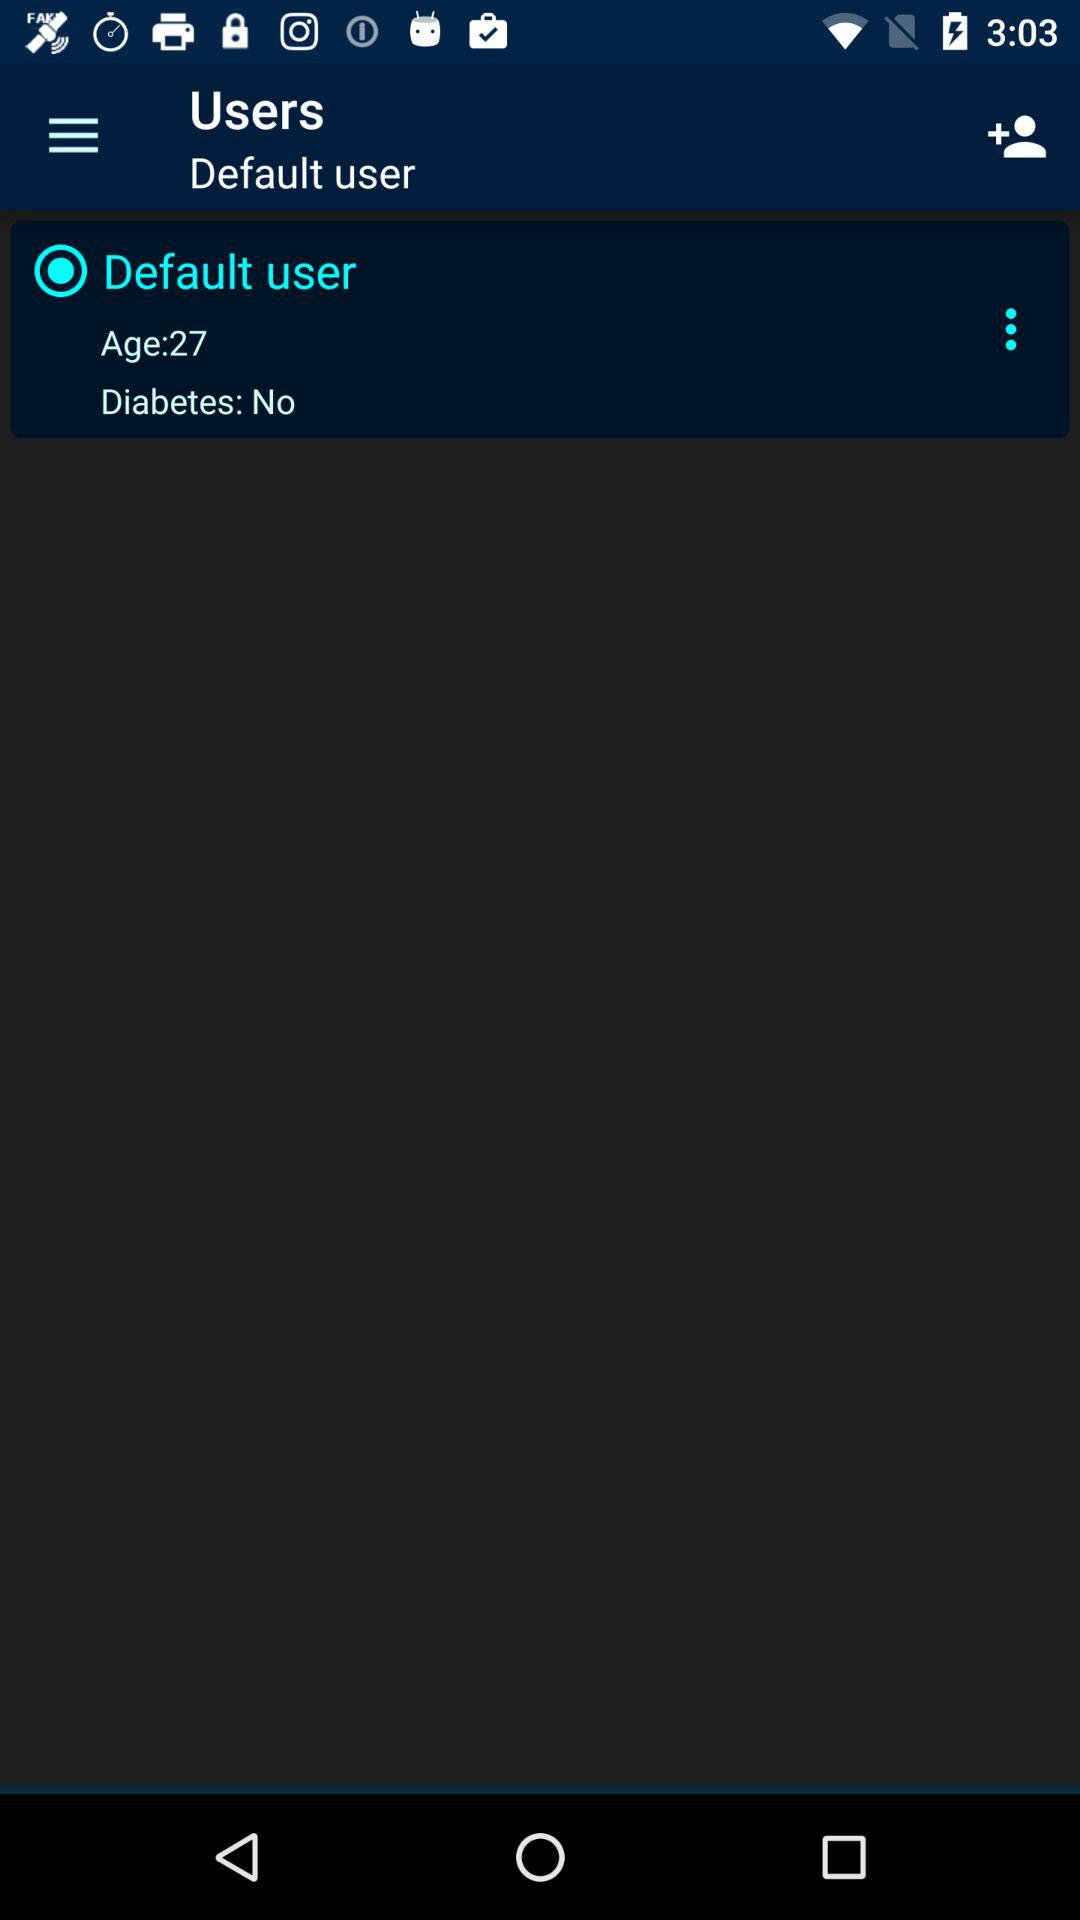Does the selected user have diabetes? The selected user does not have diabetes. 